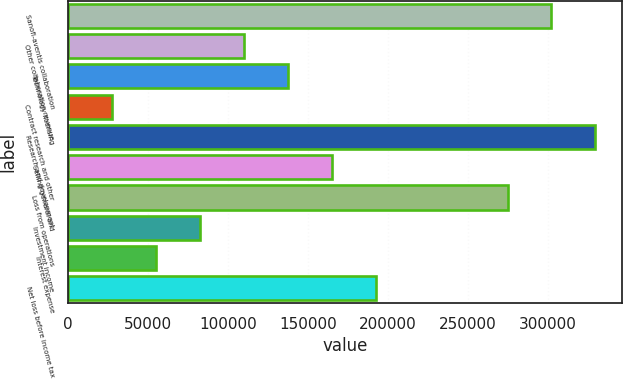<chart> <loc_0><loc_0><loc_500><loc_500><bar_chart><fcel>Sanofi-aventis collaboration<fcel>Other collaboration revenue<fcel>Technology licensing<fcel>Contract research and other<fcel>Research and development<fcel>Selling general and<fcel>Loss from operations<fcel>Investment income<fcel>Interest expense<fcel>Net loss before income tax<nl><fcel>302393<fcel>109962<fcel>137452<fcel>27491.2<fcel>329883<fcel>164942<fcel>274903<fcel>82471.6<fcel>54981.4<fcel>192432<nl></chart> 